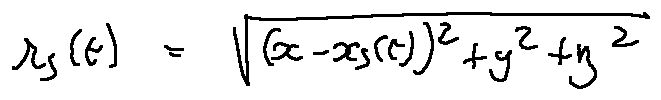Convert formula to latex. <formula><loc_0><loc_0><loc_500><loc_500>r _ { s } ( t ) = \sqrt { ( x - x _ { s } ( t ) ) ^ { 2 } + y ^ { 2 } + z ^ { 2 } }</formula> 